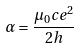<formula> <loc_0><loc_0><loc_500><loc_500>\alpha = \frac { \mu _ { 0 } c e ^ { 2 } } { 2 h }</formula> 